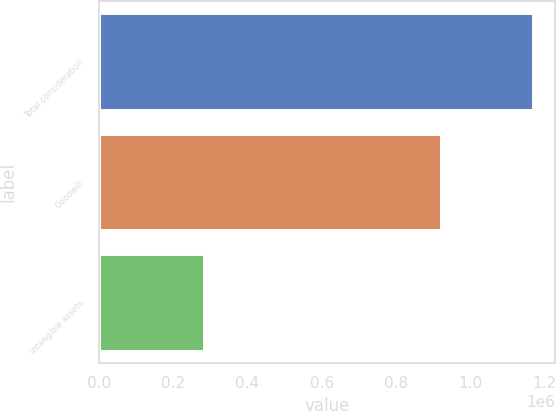Convert chart. <chart><loc_0><loc_0><loc_500><loc_500><bar_chart><fcel>Total consideration<fcel>Goodwill<fcel>Intangible assets<nl><fcel>1.17004e+06<fcel>920696<fcel>282144<nl></chart> 